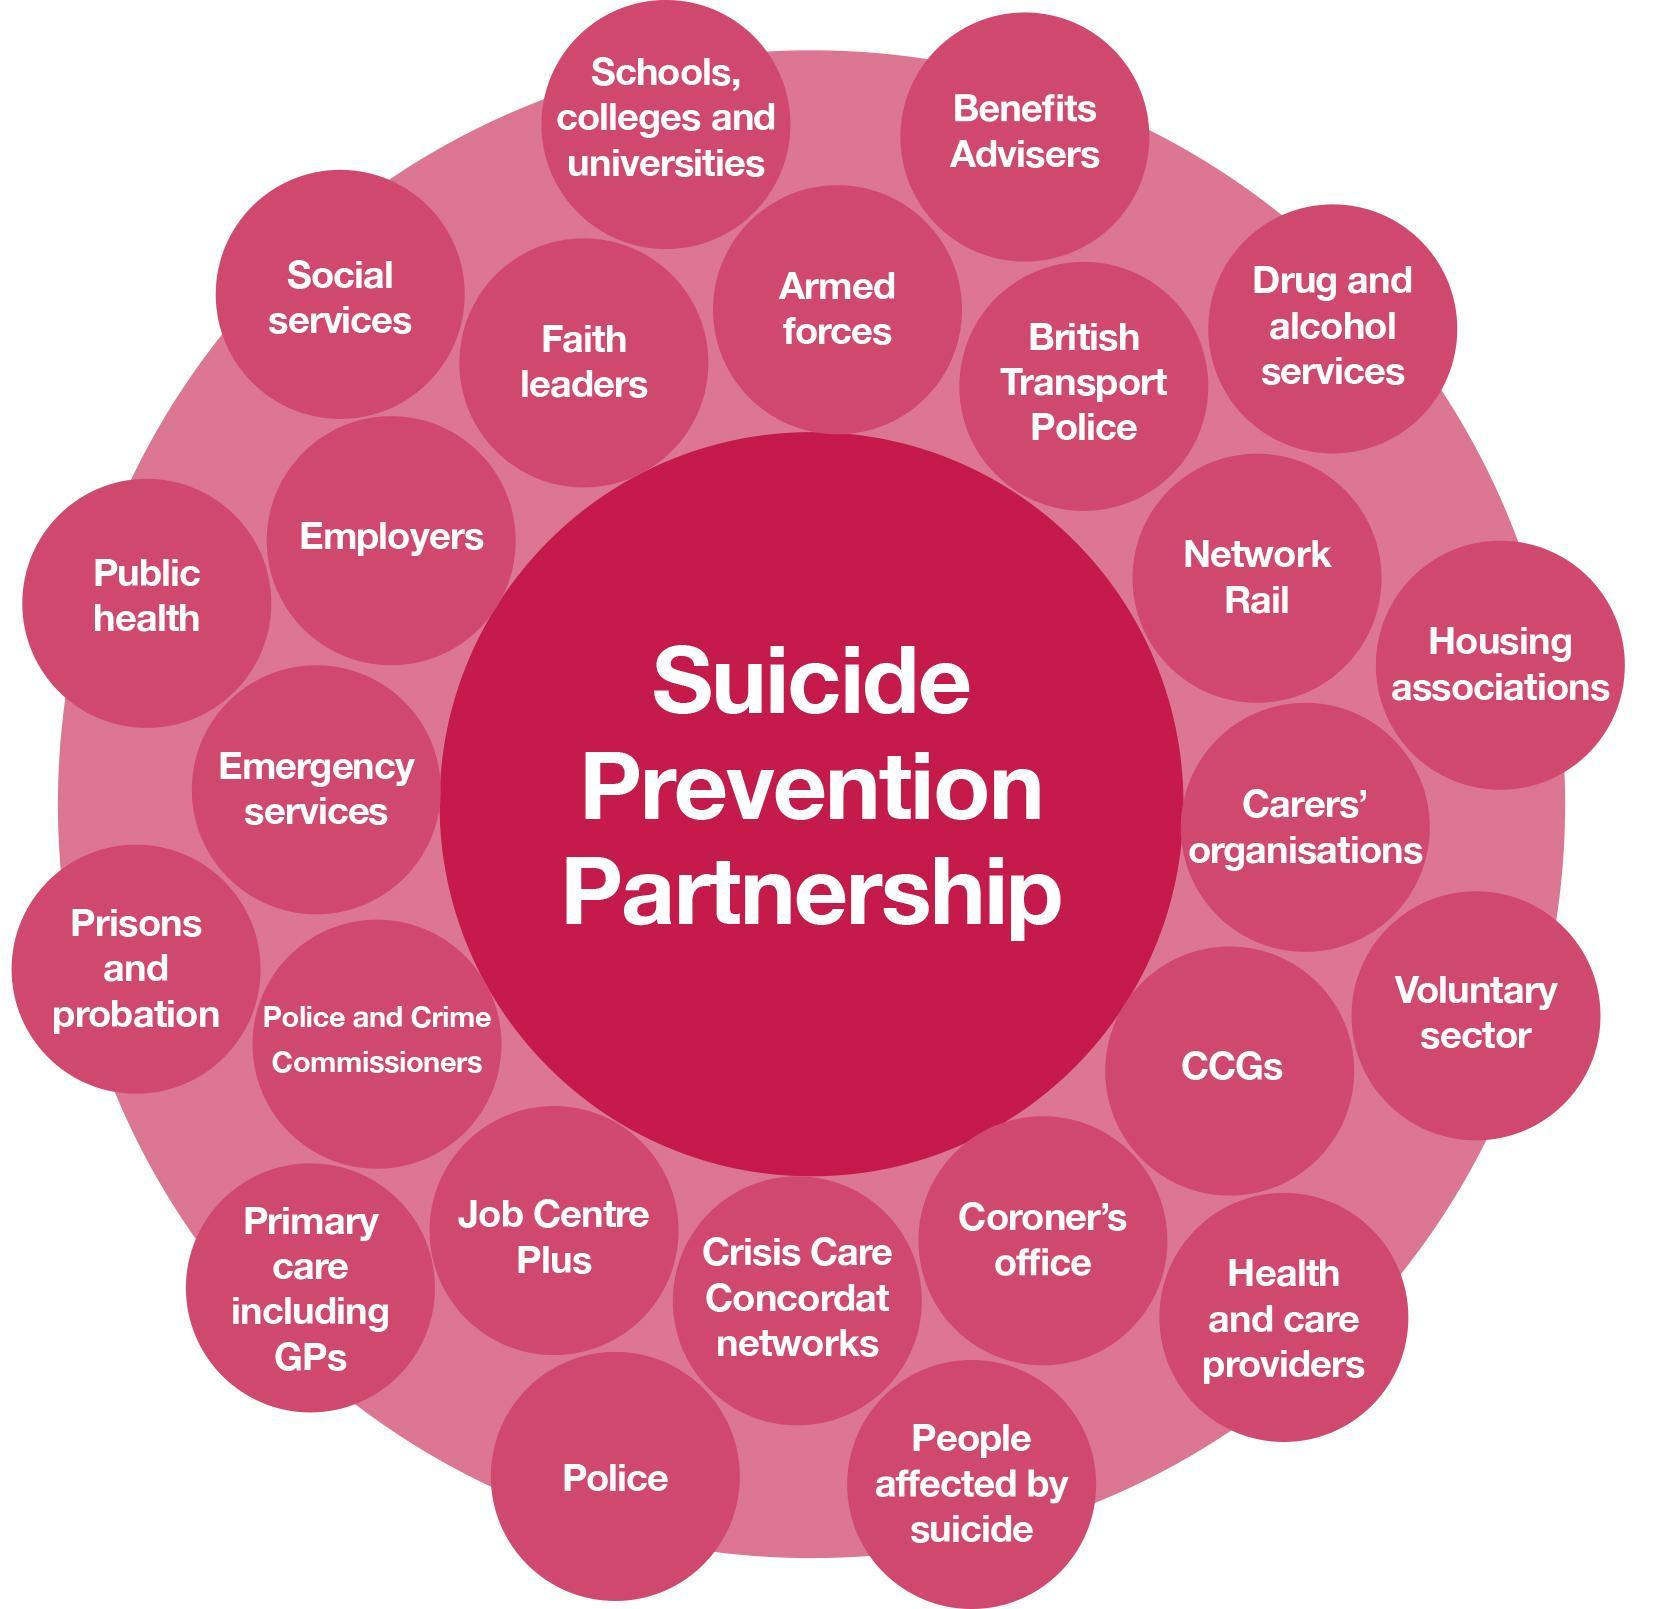How many times does the word police appear in the image ?
Answer the question with a short phrase. 3 What is written within the centre circle ? Suicide prevention partnership 